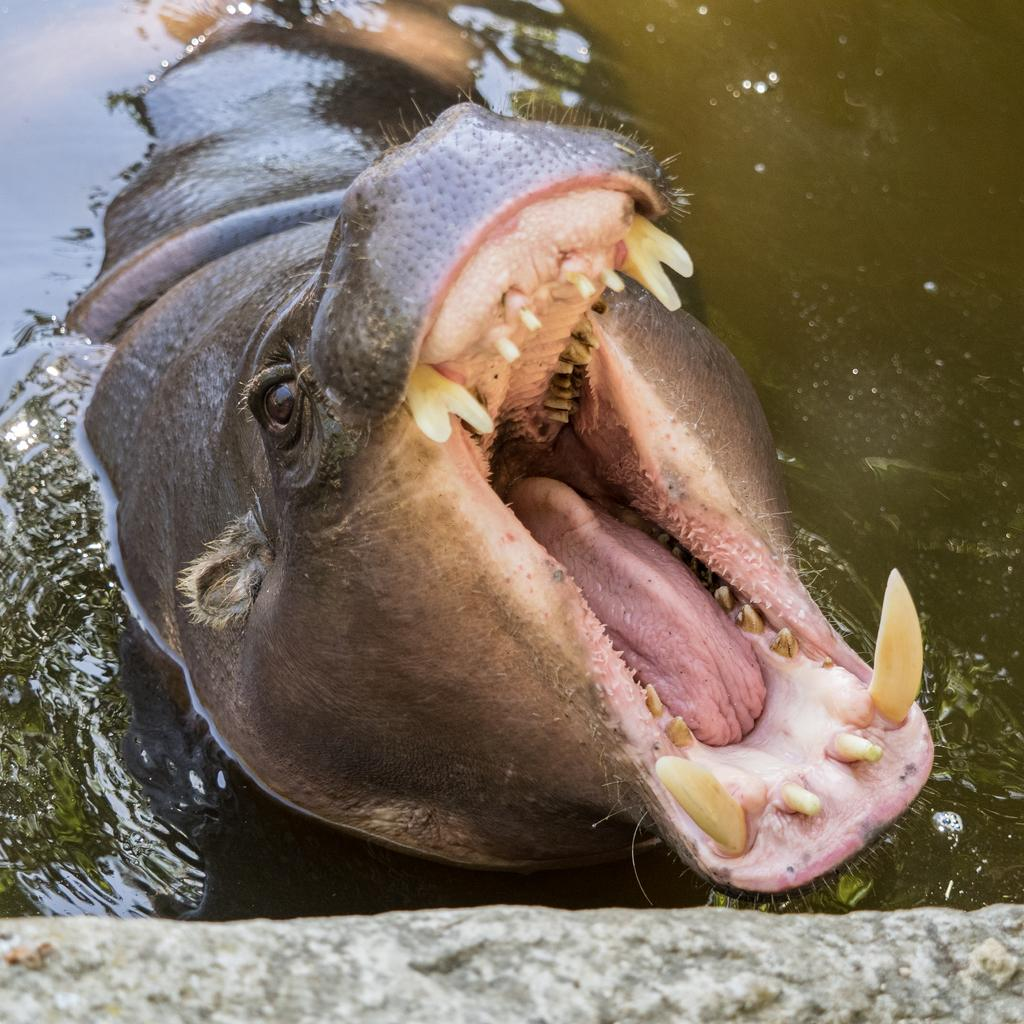What animal is the main subject of the image? There is a hippopotamus in the image. What is the color of the hippopotamus? The hippopotamus is black in color. Where is the hippopotamus located in the image? The hippopotamus is in the water. What other object can be seen in the image? There is a rock visible in the image. What type of bead is the hippopotamus wearing in the image? There is no bead present in the image, and the hippopotamus is not wearing any accessories. 